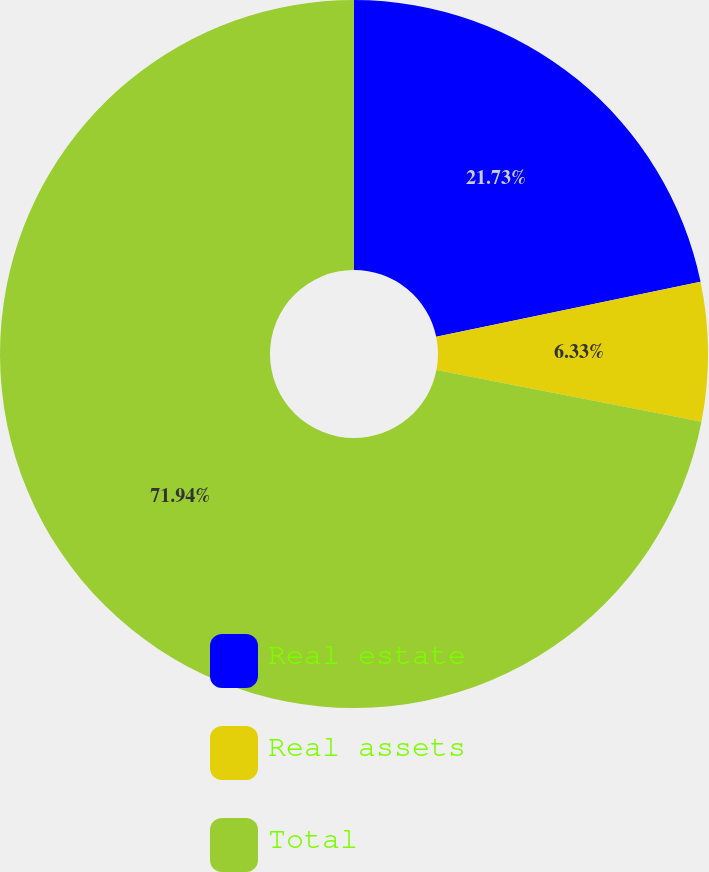<chart> <loc_0><loc_0><loc_500><loc_500><pie_chart><fcel>Real estate<fcel>Real assets<fcel>Total<nl><fcel>21.73%<fcel>6.33%<fcel>71.94%<nl></chart> 